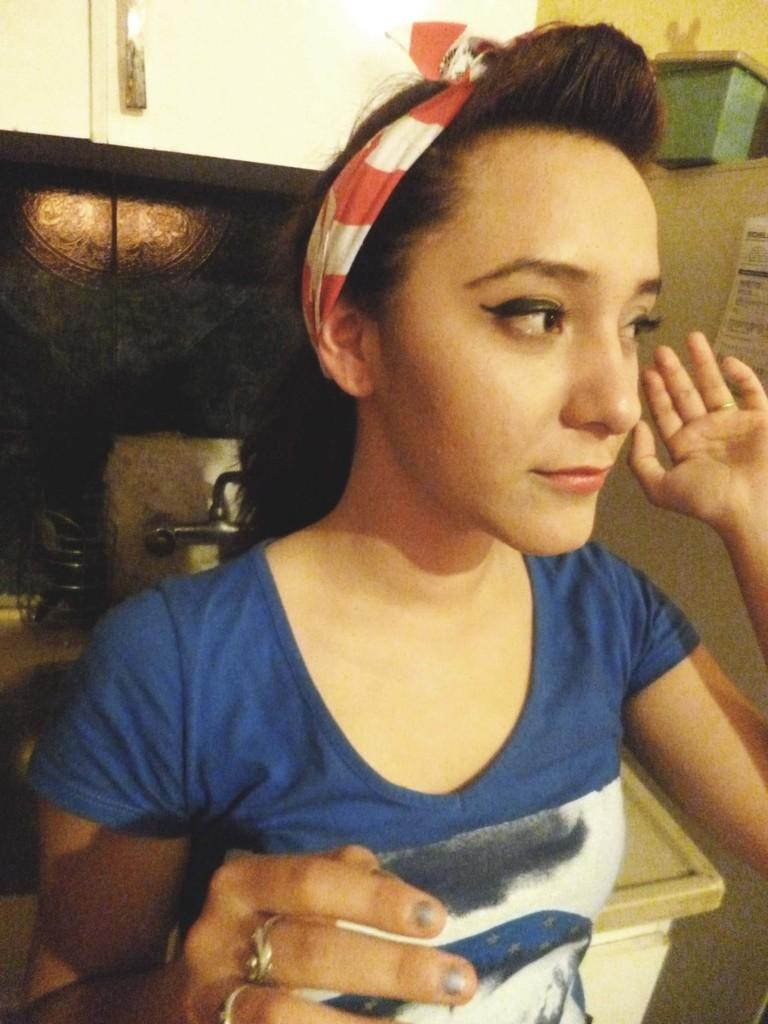Who is present in the image? There is a woman in the image. What is the woman wearing? The woman is wearing a blue t-shirt. What accessory is the woman wearing in her hair? The woman has a red hair band. What is the woman standing in front of? The woman is standing in front of a table. What can be seen behind the woman? It appears to be a wash basin behind the woman. What is above the wash basin? There is a cupboard above the wash basin. What type of reaction can be seen on the woman's face in the image? There is no indication of the woman's facial expression or any specific reaction in the image. How many letters are visible in the image? There is no mention of any letters or text in the image. 